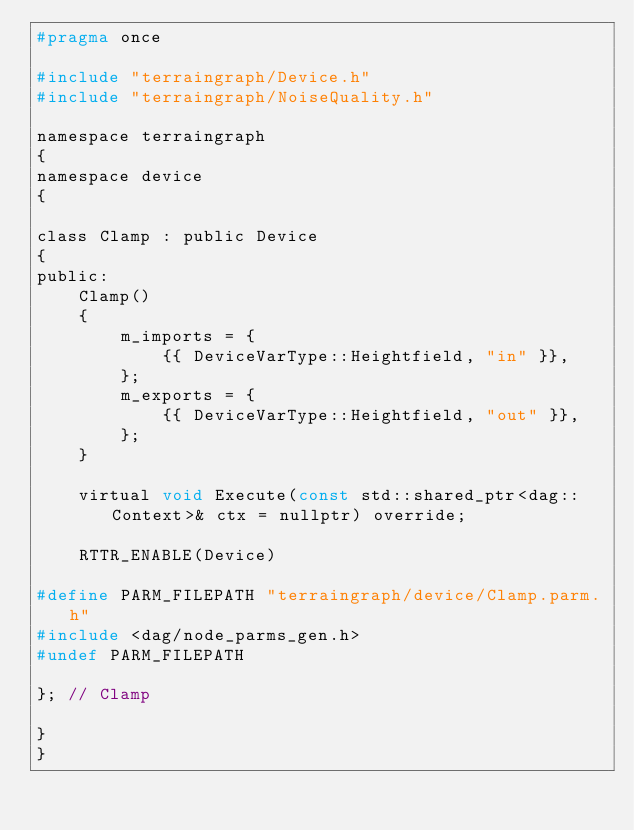<code> <loc_0><loc_0><loc_500><loc_500><_C_>#pragma once

#include "terraingraph/Device.h"
#include "terraingraph/NoiseQuality.h"

namespace terraingraph
{
namespace device
{

class Clamp : public Device
{
public:
    Clamp()
    {
        m_imports = {
            {{ DeviceVarType::Heightfield, "in" }},
        };
        m_exports = {
            {{ DeviceVarType::Heightfield, "out" }},
        };
    }

    virtual void Execute(const std::shared_ptr<dag::Context>& ctx = nullptr) override;

    RTTR_ENABLE(Device)

#define PARM_FILEPATH "terraingraph/device/Clamp.parm.h"
#include <dag/node_parms_gen.h>
#undef PARM_FILEPATH

}; // Clamp

}
}</code> 